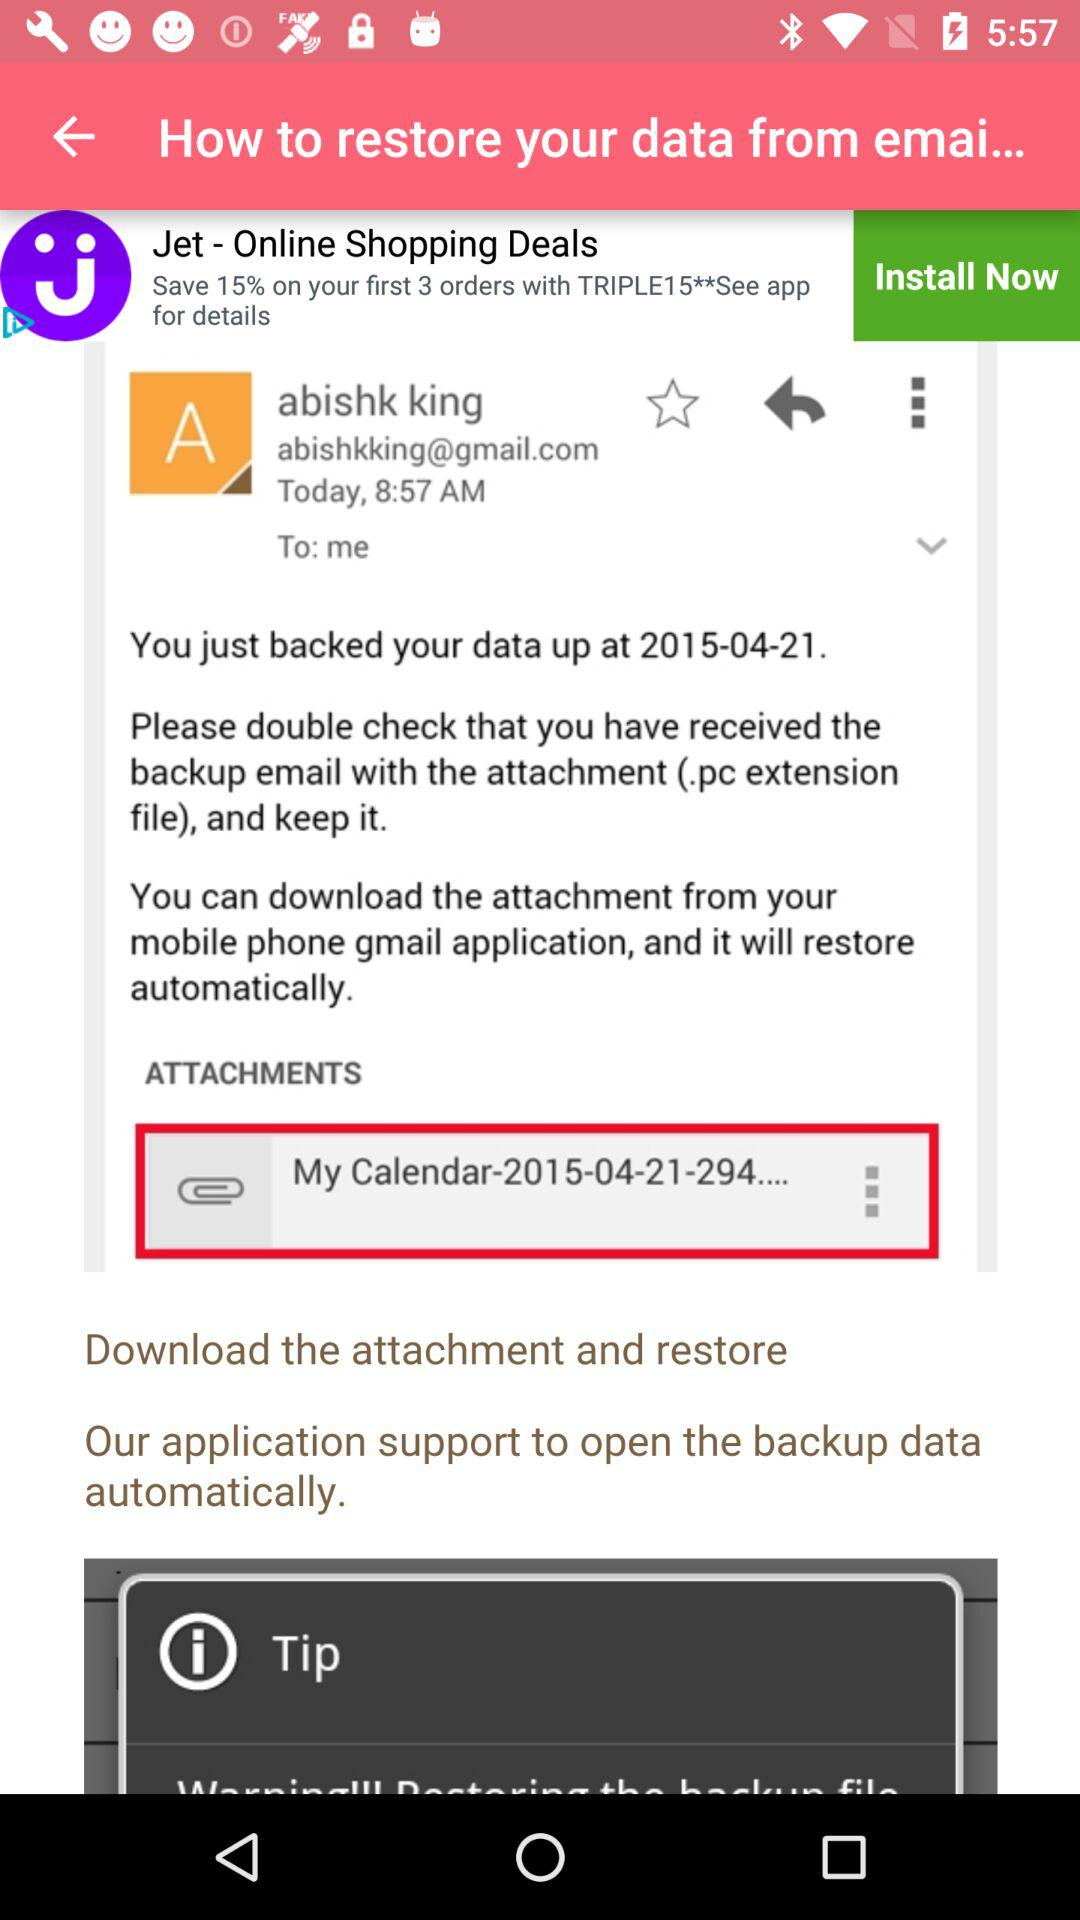At what time was the email sent? The email was sent at 8:57 AM. 